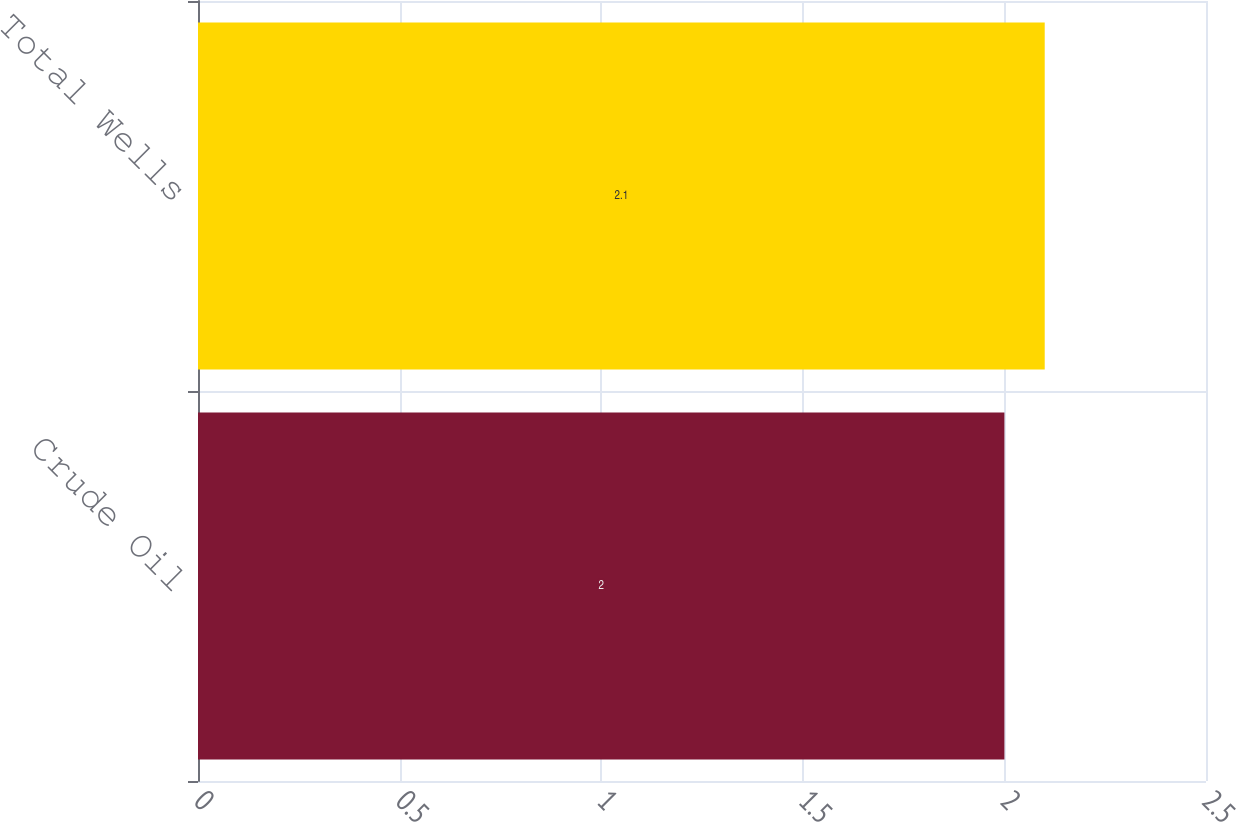Convert chart. <chart><loc_0><loc_0><loc_500><loc_500><bar_chart><fcel>Crude Oil<fcel>Total Wells<nl><fcel>2<fcel>2.1<nl></chart> 